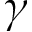Convert formula to latex. <formula><loc_0><loc_0><loc_500><loc_500>\gamma</formula> 